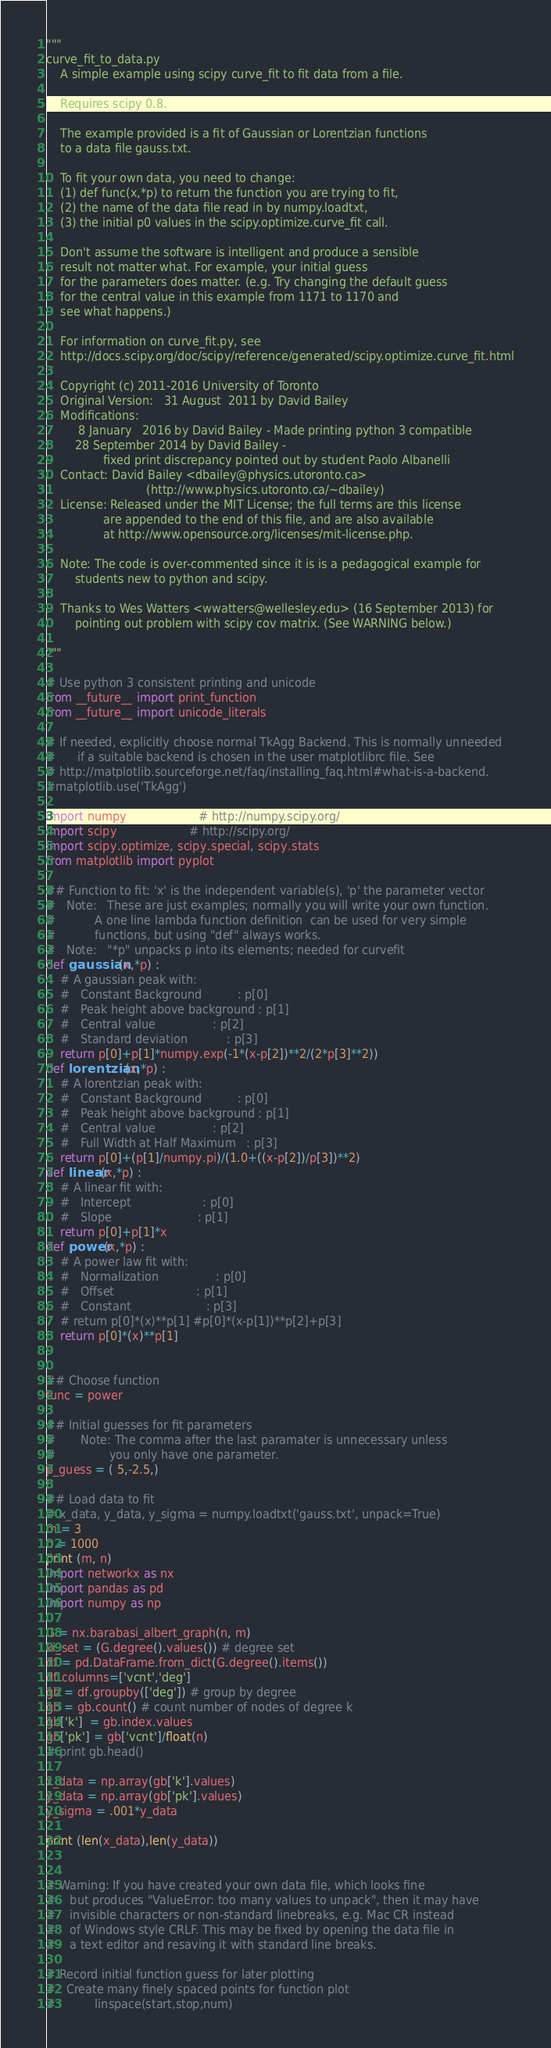<code> <loc_0><loc_0><loc_500><loc_500><_Python_>"""
curve_fit_to_data.py
    A simple example using scipy curve_fit to fit data from a file.

    Requires scipy 0.8.

    The example provided is a fit of Gaussian or Lorentzian functions
    to a data file gauss.txt.

    To fit your own data, you need to change:
    (1) def func(x,*p) to return the function you are trying to fit,
    (2) the name of the data file read in by numpy.loadtxt,
    (3) the initial p0 values in the scipy.optimize.curve_fit call.

    Don't assume the software is intelligent and produce a sensible
    result not matter what. For example, your initial guess
    for the parameters does matter. (e.g. Try changing the default guess
    for the central value in this example from 1171 to 1170 and
    see what happens.)

    For information on curve_fit.py, see
    http://docs.scipy.org/doc/scipy/reference/generated/scipy.optimize.curve_fit.html

    Copyright (c) 2011-2016 University of Toronto
    Original Version:   31 August  2011 by David Bailey
    Modifications:
         8 January   2016 by David Bailey - Made printing python 3 compatible
        28 September 2014 by David Bailey -
                fixed print discrepancy pointed out by student Paolo Albanelli
    Contact: David Bailey <dbailey@physics.utoronto.ca>
                            (http://www.physics.utoronto.ca/~dbailey)
    License: Released under the MIT License; the full terms are this license
                are appended to the end of this file, and are also available
                at http://www.opensource.org/licenses/mit-license.php.

    Note: The code is over-commented since it is is a pedagogical example for
    	students new to python and scipy.

    Thanks to Wes Watters <wwatters@wellesley.edu> (16 September 2013) for
        pointing out problem with scipy cov matrix. (See WARNING below.)

"""

# Use python 3 consistent printing and unicode
from __future__ import print_function
from __future__ import unicode_literals

# If needed, explicitly choose normal TkAgg Backend. This is normally unneeded
#      if a suitable backend is chosen in the user matplotlibrc file. See
# http://matplotlib.sourceforge.net/faq/installing_faq.html#what-is-a-backend.
#matplotlib.use('TkAgg')

import numpy                    # http://numpy.scipy.org/
import scipy                    # http://scipy.org/
import scipy.optimize, scipy.special, scipy.stats
from matplotlib import pyplot

## Function to fit: 'x' is the independent variable(s), 'p' the parameter vector
#   Note:   These are just examples; normally you will write your own function.
#           A one line lambda function definition  can be used for very simple
#           functions, but using "def" always works.
#   Note:   "*p" unpacks p into its elements; needed for curvefit
def gaussian(x,*p) :
    # A gaussian peak with:
    #   Constant Background          : p[0]
    #   Peak height above background : p[1]
    #   Central value                : p[2]
    #   Standard deviation           : p[3]
    return p[0]+p[1]*numpy.exp(-1*(x-p[2])**2/(2*p[3]**2))
def lorentzian(x,*p) :
    # A lorentzian peak with:
    #   Constant Background          : p[0]
    #   Peak height above background : p[1]
    #   Central value                : p[2]
    #   Full Width at Half Maximum   : p[3]
    return p[0]+(p[1]/numpy.pi)/(1.0+((x-p[2])/p[3])**2)
def linear(x,*p) :
    # A linear fit with:
    #   Intercept                    : p[0]
    #   Slope                        : p[1]
    return p[0]+p[1]*x
def power(x,*p) :
    # A power law fit with:
    #   Normalization                : p[0]
    #   Offset                       : p[1]
    #   Constant                     : p[3]
    # return p[0]*(x)**p[1] #p[0]*(x-p[1])**p[2]+p[3]
    return p[0]*(x)**p[1]


## Choose function
func = power

## Initial guesses for fit parameters
#       Note: The comma after the last paramater is unnecessary unless
#               you only have one parameter.
p_guess = ( 5,-2.5,)

## Load data to fit
# x_data, y_data, y_sigma = numpy.loadtxt('gauss.txt', unpack=True)
m = 3
n = 1000
print (m, n)
import networkx as nx
import pandas as pd
import numpy as np

G = nx.barabasi_albert_graph(n, m)
ki_set = (G.degree().values()) # degree set
df = pd.DataFrame.from_dict(G.degree().items())
df.columns=['vcnt','deg']
gb = df.groupby(['deg']) # group by degree
gb = gb.count() # count number of nodes of degree k
gb['k']  = gb.index.values
gb['pk'] = gb['vcnt']/float(n)
# print gb.head()

x_data = np.array(gb['k'].values)
y_data = np.array(gb['pk'].values)
y_sigma = .001*y_data

print (len(x_data),len(y_data))


# Warning: If you have created your own data file, which looks fine
#    but produces "ValueError: too many values to unpack", then it may have
#    invisible characters or non-standard linebreaks, e.g. Mac CR instead
#    of Windows style CRLF. This may be fixed by opening the data file in
#    a text editor and resaving it with standard line breaks.

# Record initial function guess for later plotting
#   Create many finely spaced points for function plot
#           linspace(start,stop,num)</code> 